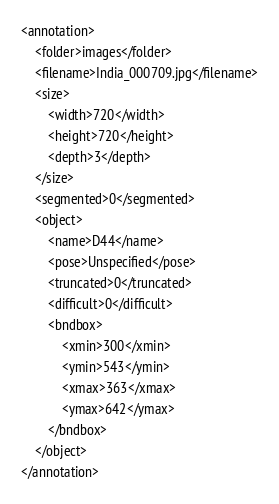<code> <loc_0><loc_0><loc_500><loc_500><_XML_><annotation>
	<folder>images</folder>
	<filename>India_000709.jpg</filename>
	<size>
		<width>720</width>
		<height>720</height>
		<depth>3</depth>
	</size>
	<segmented>0</segmented>
	<object>
		<name>D44</name>
		<pose>Unspecified</pose>
		<truncated>0</truncated>
		<difficult>0</difficult>
		<bndbox>
			<xmin>300</xmin>
			<ymin>543</ymin>
			<xmax>363</xmax>
			<ymax>642</ymax>
		</bndbox>
	</object>
</annotation></code> 